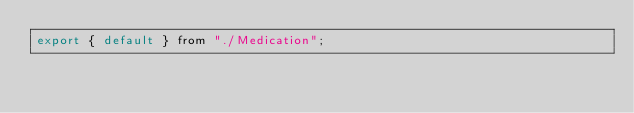Convert code to text. <code><loc_0><loc_0><loc_500><loc_500><_JavaScript_>export { default } from "./Medication";
</code> 